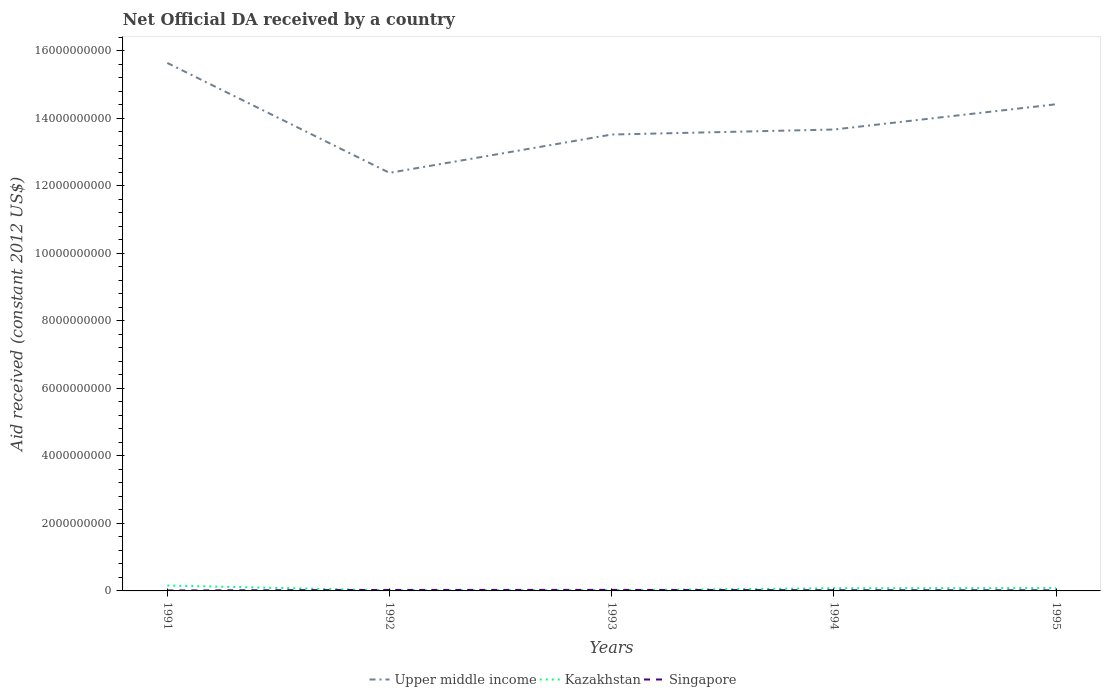Does the line corresponding to Singapore intersect with the line corresponding to Upper middle income?
Provide a short and direct response. No. Across all years, what is the maximum net official development assistance aid received in Upper middle income?
Provide a succinct answer. 1.24e+1. In which year was the net official development assistance aid received in Kazakhstan maximum?
Provide a succinct answer. 1992. What is the total net official development assistance aid received in Kazakhstan in the graph?
Provide a succinct answer. -6.25e+07. What is the difference between the highest and the second highest net official development assistance aid received in Singapore?
Offer a terse response. 1.70e+07. How many lines are there?
Your answer should be compact. 3. How many years are there in the graph?
Provide a short and direct response. 5. What is the difference between two consecutive major ticks on the Y-axis?
Offer a terse response. 2.00e+09. How many legend labels are there?
Keep it short and to the point. 3. How are the legend labels stacked?
Give a very brief answer. Horizontal. What is the title of the graph?
Offer a terse response. Net Official DA received by a country. Does "Latin America(all income levels)" appear as one of the legend labels in the graph?
Keep it short and to the point. No. What is the label or title of the Y-axis?
Give a very brief answer. Aid received (constant 2012 US$). What is the Aid received (constant 2012 US$) in Upper middle income in 1991?
Your answer should be compact. 1.56e+1. What is the Aid received (constant 2012 US$) in Kazakhstan in 1991?
Provide a short and direct response. 1.60e+08. What is the Aid received (constant 2012 US$) in Singapore in 1991?
Your response must be concise. 1.34e+07. What is the Aid received (constant 2012 US$) of Upper middle income in 1992?
Your response must be concise. 1.24e+1. What is the Aid received (constant 2012 US$) of Kazakhstan in 1992?
Offer a very short reply. 1.74e+07. What is the Aid received (constant 2012 US$) of Singapore in 1992?
Your answer should be compact. 2.89e+07. What is the Aid received (constant 2012 US$) in Upper middle income in 1993?
Offer a terse response. 1.35e+1. What is the Aid received (constant 2012 US$) of Kazakhstan in 1993?
Ensure brevity in your answer.  2.28e+07. What is the Aid received (constant 2012 US$) in Singapore in 1993?
Your answer should be compact. 3.04e+07. What is the Aid received (constant 2012 US$) in Upper middle income in 1994?
Make the answer very short. 1.37e+1. What is the Aid received (constant 2012 US$) in Kazakhstan in 1994?
Offer a terse response. 7.88e+07. What is the Aid received (constant 2012 US$) in Singapore in 1994?
Offer a very short reply. 2.03e+07. What is the Aid received (constant 2012 US$) in Upper middle income in 1995?
Keep it short and to the point. 1.44e+1. What is the Aid received (constant 2012 US$) in Kazakhstan in 1995?
Your answer should be compact. 8.53e+07. What is the Aid received (constant 2012 US$) in Singapore in 1995?
Provide a succinct answer. 1.81e+07. Across all years, what is the maximum Aid received (constant 2012 US$) of Upper middle income?
Your answer should be compact. 1.56e+1. Across all years, what is the maximum Aid received (constant 2012 US$) in Kazakhstan?
Offer a terse response. 1.60e+08. Across all years, what is the maximum Aid received (constant 2012 US$) in Singapore?
Provide a succinct answer. 3.04e+07. Across all years, what is the minimum Aid received (constant 2012 US$) in Upper middle income?
Your response must be concise. 1.24e+1. Across all years, what is the minimum Aid received (constant 2012 US$) of Kazakhstan?
Your answer should be compact. 1.74e+07. Across all years, what is the minimum Aid received (constant 2012 US$) in Singapore?
Your response must be concise. 1.34e+07. What is the total Aid received (constant 2012 US$) of Upper middle income in the graph?
Ensure brevity in your answer.  6.96e+1. What is the total Aid received (constant 2012 US$) of Kazakhstan in the graph?
Provide a succinct answer. 3.64e+08. What is the total Aid received (constant 2012 US$) of Singapore in the graph?
Offer a terse response. 1.11e+08. What is the difference between the Aid received (constant 2012 US$) in Upper middle income in 1991 and that in 1992?
Your answer should be very brief. 3.25e+09. What is the difference between the Aid received (constant 2012 US$) of Kazakhstan in 1991 and that in 1992?
Give a very brief answer. 1.43e+08. What is the difference between the Aid received (constant 2012 US$) of Singapore in 1991 and that in 1992?
Provide a succinct answer. -1.55e+07. What is the difference between the Aid received (constant 2012 US$) of Upper middle income in 1991 and that in 1993?
Your answer should be compact. 2.12e+09. What is the difference between the Aid received (constant 2012 US$) of Kazakhstan in 1991 and that in 1993?
Keep it short and to the point. 1.37e+08. What is the difference between the Aid received (constant 2012 US$) in Singapore in 1991 and that in 1993?
Your response must be concise. -1.70e+07. What is the difference between the Aid received (constant 2012 US$) of Upper middle income in 1991 and that in 1994?
Keep it short and to the point. 1.97e+09. What is the difference between the Aid received (constant 2012 US$) in Kazakhstan in 1991 and that in 1994?
Give a very brief answer. 8.13e+07. What is the difference between the Aid received (constant 2012 US$) in Singapore in 1991 and that in 1994?
Provide a succinct answer. -6.91e+06. What is the difference between the Aid received (constant 2012 US$) of Upper middle income in 1991 and that in 1995?
Your answer should be very brief. 1.22e+09. What is the difference between the Aid received (constant 2012 US$) in Kazakhstan in 1991 and that in 1995?
Offer a terse response. 7.47e+07. What is the difference between the Aid received (constant 2012 US$) in Singapore in 1991 and that in 1995?
Give a very brief answer. -4.76e+06. What is the difference between the Aid received (constant 2012 US$) in Upper middle income in 1992 and that in 1993?
Offer a very short reply. -1.13e+09. What is the difference between the Aid received (constant 2012 US$) of Kazakhstan in 1992 and that in 1993?
Offer a very short reply. -5.40e+06. What is the difference between the Aid received (constant 2012 US$) of Singapore in 1992 and that in 1993?
Offer a terse response. -1.54e+06. What is the difference between the Aid received (constant 2012 US$) in Upper middle income in 1992 and that in 1994?
Provide a succinct answer. -1.28e+09. What is the difference between the Aid received (constant 2012 US$) of Kazakhstan in 1992 and that in 1994?
Provide a succinct answer. -6.14e+07. What is the difference between the Aid received (constant 2012 US$) of Singapore in 1992 and that in 1994?
Your answer should be very brief. 8.60e+06. What is the difference between the Aid received (constant 2012 US$) of Upper middle income in 1992 and that in 1995?
Give a very brief answer. -2.03e+09. What is the difference between the Aid received (constant 2012 US$) in Kazakhstan in 1992 and that in 1995?
Your response must be concise. -6.79e+07. What is the difference between the Aid received (constant 2012 US$) in Singapore in 1992 and that in 1995?
Make the answer very short. 1.08e+07. What is the difference between the Aid received (constant 2012 US$) in Upper middle income in 1993 and that in 1994?
Your answer should be compact. -1.48e+08. What is the difference between the Aid received (constant 2012 US$) in Kazakhstan in 1993 and that in 1994?
Make the answer very short. -5.60e+07. What is the difference between the Aid received (constant 2012 US$) of Singapore in 1993 and that in 1994?
Your answer should be very brief. 1.01e+07. What is the difference between the Aid received (constant 2012 US$) in Upper middle income in 1993 and that in 1995?
Ensure brevity in your answer.  -8.97e+08. What is the difference between the Aid received (constant 2012 US$) in Kazakhstan in 1993 and that in 1995?
Make the answer very short. -6.25e+07. What is the difference between the Aid received (constant 2012 US$) in Singapore in 1993 and that in 1995?
Offer a very short reply. 1.23e+07. What is the difference between the Aid received (constant 2012 US$) in Upper middle income in 1994 and that in 1995?
Make the answer very short. -7.48e+08. What is the difference between the Aid received (constant 2012 US$) of Kazakhstan in 1994 and that in 1995?
Offer a very short reply. -6.55e+06. What is the difference between the Aid received (constant 2012 US$) in Singapore in 1994 and that in 1995?
Your response must be concise. 2.15e+06. What is the difference between the Aid received (constant 2012 US$) of Upper middle income in 1991 and the Aid received (constant 2012 US$) of Kazakhstan in 1992?
Offer a very short reply. 1.56e+1. What is the difference between the Aid received (constant 2012 US$) of Upper middle income in 1991 and the Aid received (constant 2012 US$) of Singapore in 1992?
Provide a short and direct response. 1.56e+1. What is the difference between the Aid received (constant 2012 US$) of Kazakhstan in 1991 and the Aid received (constant 2012 US$) of Singapore in 1992?
Your answer should be compact. 1.31e+08. What is the difference between the Aid received (constant 2012 US$) in Upper middle income in 1991 and the Aid received (constant 2012 US$) in Kazakhstan in 1993?
Provide a succinct answer. 1.56e+1. What is the difference between the Aid received (constant 2012 US$) of Upper middle income in 1991 and the Aid received (constant 2012 US$) of Singapore in 1993?
Ensure brevity in your answer.  1.56e+1. What is the difference between the Aid received (constant 2012 US$) of Kazakhstan in 1991 and the Aid received (constant 2012 US$) of Singapore in 1993?
Provide a succinct answer. 1.30e+08. What is the difference between the Aid received (constant 2012 US$) in Upper middle income in 1991 and the Aid received (constant 2012 US$) in Kazakhstan in 1994?
Offer a very short reply. 1.56e+1. What is the difference between the Aid received (constant 2012 US$) in Upper middle income in 1991 and the Aid received (constant 2012 US$) in Singapore in 1994?
Ensure brevity in your answer.  1.56e+1. What is the difference between the Aid received (constant 2012 US$) in Kazakhstan in 1991 and the Aid received (constant 2012 US$) in Singapore in 1994?
Your answer should be compact. 1.40e+08. What is the difference between the Aid received (constant 2012 US$) in Upper middle income in 1991 and the Aid received (constant 2012 US$) in Kazakhstan in 1995?
Your answer should be very brief. 1.56e+1. What is the difference between the Aid received (constant 2012 US$) of Upper middle income in 1991 and the Aid received (constant 2012 US$) of Singapore in 1995?
Your answer should be very brief. 1.56e+1. What is the difference between the Aid received (constant 2012 US$) in Kazakhstan in 1991 and the Aid received (constant 2012 US$) in Singapore in 1995?
Ensure brevity in your answer.  1.42e+08. What is the difference between the Aid received (constant 2012 US$) of Upper middle income in 1992 and the Aid received (constant 2012 US$) of Kazakhstan in 1993?
Your answer should be very brief. 1.24e+1. What is the difference between the Aid received (constant 2012 US$) in Upper middle income in 1992 and the Aid received (constant 2012 US$) in Singapore in 1993?
Offer a terse response. 1.24e+1. What is the difference between the Aid received (constant 2012 US$) of Kazakhstan in 1992 and the Aid received (constant 2012 US$) of Singapore in 1993?
Give a very brief answer. -1.30e+07. What is the difference between the Aid received (constant 2012 US$) of Upper middle income in 1992 and the Aid received (constant 2012 US$) of Kazakhstan in 1994?
Provide a succinct answer. 1.23e+1. What is the difference between the Aid received (constant 2012 US$) of Upper middle income in 1992 and the Aid received (constant 2012 US$) of Singapore in 1994?
Make the answer very short. 1.24e+1. What is the difference between the Aid received (constant 2012 US$) of Kazakhstan in 1992 and the Aid received (constant 2012 US$) of Singapore in 1994?
Provide a short and direct response. -2.89e+06. What is the difference between the Aid received (constant 2012 US$) in Upper middle income in 1992 and the Aid received (constant 2012 US$) in Kazakhstan in 1995?
Provide a short and direct response. 1.23e+1. What is the difference between the Aid received (constant 2012 US$) in Upper middle income in 1992 and the Aid received (constant 2012 US$) in Singapore in 1995?
Make the answer very short. 1.24e+1. What is the difference between the Aid received (constant 2012 US$) in Kazakhstan in 1992 and the Aid received (constant 2012 US$) in Singapore in 1995?
Your answer should be very brief. -7.40e+05. What is the difference between the Aid received (constant 2012 US$) in Upper middle income in 1993 and the Aid received (constant 2012 US$) in Kazakhstan in 1994?
Offer a very short reply. 1.34e+1. What is the difference between the Aid received (constant 2012 US$) in Upper middle income in 1993 and the Aid received (constant 2012 US$) in Singapore in 1994?
Provide a short and direct response. 1.35e+1. What is the difference between the Aid received (constant 2012 US$) of Kazakhstan in 1993 and the Aid received (constant 2012 US$) of Singapore in 1994?
Offer a very short reply. 2.51e+06. What is the difference between the Aid received (constant 2012 US$) in Upper middle income in 1993 and the Aid received (constant 2012 US$) in Kazakhstan in 1995?
Offer a very short reply. 1.34e+1. What is the difference between the Aid received (constant 2012 US$) of Upper middle income in 1993 and the Aid received (constant 2012 US$) of Singapore in 1995?
Your answer should be very brief. 1.35e+1. What is the difference between the Aid received (constant 2012 US$) in Kazakhstan in 1993 and the Aid received (constant 2012 US$) in Singapore in 1995?
Your answer should be very brief. 4.66e+06. What is the difference between the Aid received (constant 2012 US$) in Upper middle income in 1994 and the Aid received (constant 2012 US$) in Kazakhstan in 1995?
Provide a short and direct response. 1.36e+1. What is the difference between the Aid received (constant 2012 US$) in Upper middle income in 1994 and the Aid received (constant 2012 US$) in Singapore in 1995?
Your answer should be very brief. 1.36e+1. What is the difference between the Aid received (constant 2012 US$) of Kazakhstan in 1994 and the Aid received (constant 2012 US$) of Singapore in 1995?
Your answer should be compact. 6.06e+07. What is the average Aid received (constant 2012 US$) of Upper middle income per year?
Keep it short and to the point. 1.39e+1. What is the average Aid received (constant 2012 US$) in Kazakhstan per year?
Provide a short and direct response. 7.29e+07. What is the average Aid received (constant 2012 US$) in Singapore per year?
Offer a very short reply. 2.22e+07. In the year 1991, what is the difference between the Aid received (constant 2012 US$) of Upper middle income and Aid received (constant 2012 US$) of Kazakhstan?
Your answer should be very brief. 1.55e+1. In the year 1991, what is the difference between the Aid received (constant 2012 US$) in Upper middle income and Aid received (constant 2012 US$) in Singapore?
Ensure brevity in your answer.  1.56e+1. In the year 1991, what is the difference between the Aid received (constant 2012 US$) in Kazakhstan and Aid received (constant 2012 US$) in Singapore?
Offer a terse response. 1.47e+08. In the year 1992, what is the difference between the Aid received (constant 2012 US$) in Upper middle income and Aid received (constant 2012 US$) in Kazakhstan?
Make the answer very short. 1.24e+1. In the year 1992, what is the difference between the Aid received (constant 2012 US$) in Upper middle income and Aid received (constant 2012 US$) in Singapore?
Make the answer very short. 1.24e+1. In the year 1992, what is the difference between the Aid received (constant 2012 US$) in Kazakhstan and Aid received (constant 2012 US$) in Singapore?
Give a very brief answer. -1.15e+07. In the year 1993, what is the difference between the Aid received (constant 2012 US$) of Upper middle income and Aid received (constant 2012 US$) of Kazakhstan?
Make the answer very short. 1.35e+1. In the year 1993, what is the difference between the Aid received (constant 2012 US$) in Upper middle income and Aid received (constant 2012 US$) in Singapore?
Your answer should be compact. 1.35e+1. In the year 1993, what is the difference between the Aid received (constant 2012 US$) of Kazakhstan and Aid received (constant 2012 US$) of Singapore?
Make the answer very short. -7.63e+06. In the year 1994, what is the difference between the Aid received (constant 2012 US$) of Upper middle income and Aid received (constant 2012 US$) of Kazakhstan?
Your answer should be compact. 1.36e+1. In the year 1994, what is the difference between the Aid received (constant 2012 US$) of Upper middle income and Aid received (constant 2012 US$) of Singapore?
Make the answer very short. 1.36e+1. In the year 1994, what is the difference between the Aid received (constant 2012 US$) of Kazakhstan and Aid received (constant 2012 US$) of Singapore?
Your answer should be compact. 5.85e+07. In the year 1995, what is the difference between the Aid received (constant 2012 US$) in Upper middle income and Aid received (constant 2012 US$) in Kazakhstan?
Offer a terse response. 1.43e+1. In the year 1995, what is the difference between the Aid received (constant 2012 US$) in Upper middle income and Aid received (constant 2012 US$) in Singapore?
Make the answer very short. 1.44e+1. In the year 1995, what is the difference between the Aid received (constant 2012 US$) of Kazakhstan and Aid received (constant 2012 US$) of Singapore?
Your response must be concise. 6.72e+07. What is the ratio of the Aid received (constant 2012 US$) of Upper middle income in 1991 to that in 1992?
Your answer should be compact. 1.26. What is the ratio of the Aid received (constant 2012 US$) in Kazakhstan in 1991 to that in 1992?
Provide a succinct answer. 9.2. What is the ratio of the Aid received (constant 2012 US$) of Singapore in 1991 to that in 1992?
Make the answer very short. 0.46. What is the ratio of the Aid received (constant 2012 US$) of Upper middle income in 1991 to that in 1993?
Provide a succinct answer. 1.16. What is the ratio of the Aid received (constant 2012 US$) of Kazakhstan in 1991 to that in 1993?
Your response must be concise. 7.02. What is the ratio of the Aid received (constant 2012 US$) in Singapore in 1991 to that in 1993?
Your response must be concise. 0.44. What is the ratio of the Aid received (constant 2012 US$) in Upper middle income in 1991 to that in 1994?
Make the answer very short. 1.14. What is the ratio of the Aid received (constant 2012 US$) of Kazakhstan in 1991 to that in 1994?
Offer a very short reply. 2.03. What is the ratio of the Aid received (constant 2012 US$) of Singapore in 1991 to that in 1994?
Offer a terse response. 0.66. What is the ratio of the Aid received (constant 2012 US$) of Upper middle income in 1991 to that in 1995?
Your answer should be compact. 1.08. What is the ratio of the Aid received (constant 2012 US$) of Kazakhstan in 1991 to that in 1995?
Your response must be concise. 1.88. What is the ratio of the Aid received (constant 2012 US$) in Singapore in 1991 to that in 1995?
Your answer should be very brief. 0.74. What is the ratio of the Aid received (constant 2012 US$) of Upper middle income in 1992 to that in 1993?
Offer a terse response. 0.92. What is the ratio of the Aid received (constant 2012 US$) in Kazakhstan in 1992 to that in 1993?
Your answer should be compact. 0.76. What is the ratio of the Aid received (constant 2012 US$) of Singapore in 1992 to that in 1993?
Offer a terse response. 0.95. What is the ratio of the Aid received (constant 2012 US$) in Upper middle income in 1992 to that in 1994?
Provide a succinct answer. 0.91. What is the ratio of the Aid received (constant 2012 US$) in Kazakhstan in 1992 to that in 1994?
Provide a succinct answer. 0.22. What is the ratio of the Aid received (constant 2012 US$) of Singapore in 1992 to that in 1994?
Your answer should be very brief. 1.42. What is the ratio of the Aid received (constant 2012 US$) in Upper middle income in 1992 to that in 1995?
Offer a terse response. 0.86. What is the ratio of the Aid received (constant 2012 US$) in Kazakhstan in 1992 to that in 1995?
Offer a very short reply. 0.2. What is the ratio of the Aid received (constant 2012 US$) of Singapore in 1992 to that in 1995?
Your response must be concise. 1.59. What is the ratio of the Aid received (constant 2012 US$) in Kazakhstan in 1993 to that in 1994?
Keep it short and to the point. 0.29. What is the ratio of the Aid received (constant 2012 US$) in Upper middle income in 1993 to that in 1995?
Offer a terse response. 0.94. What is the ratio of the Aid received (constant 2012 US$) in Kazakhstan in 1993 to that in 1995?
Provide a short and direct response. 0.27. What is the ratio of the Aid received (constant 2012 US$) in Singapore in 1993 to that in 1995?
Keep it short and to the point. 1.68. What is the ratio of the Aid received (constant 2012 US$) of Upper middle income in 1994 to that in 1995?
Keep it short and to the point. 0.95. What is the ratio of the Aid received (constant 2012 US$) of Kazakhstan in 1994 to that in 1995?
Keep it short and to the point. 0.92. What is the ratio of the Aid received (constant 2012 US$) of Singapore in 1994 to that in 1995?
Ensure brevity in your answer.  1.12. What is the difference between the highest and the second highest Aid received (constant 2012 US$) in Upper middle income?
Offer a terse response. 1.22e+09. What is the difference between the highest and the second highest Aid received (constant 2012 US$) of Kazakhstan?
Ensure brevity in your answer.  7.47e+07. What is the difference between the highest and the second highest Aid received (constant 2012 US$) of Singapore?
Make the answer very short. 1.54e+06. What is the difference between the highest and the lowest Aid received (constant 2012 US$) of Upper middle income?
Offer a very short reply. 3.25e+09. What is the difference between the highest and the lowest Aid received (constant 2012 US$) of Kazakhstan?
Offer a very short reply. 1.43e+08. What is the difference between the highest and the lowest Aid received (constant 2012 US$) in Singapore?
Keep it short and to the point. 1.70e+07. 